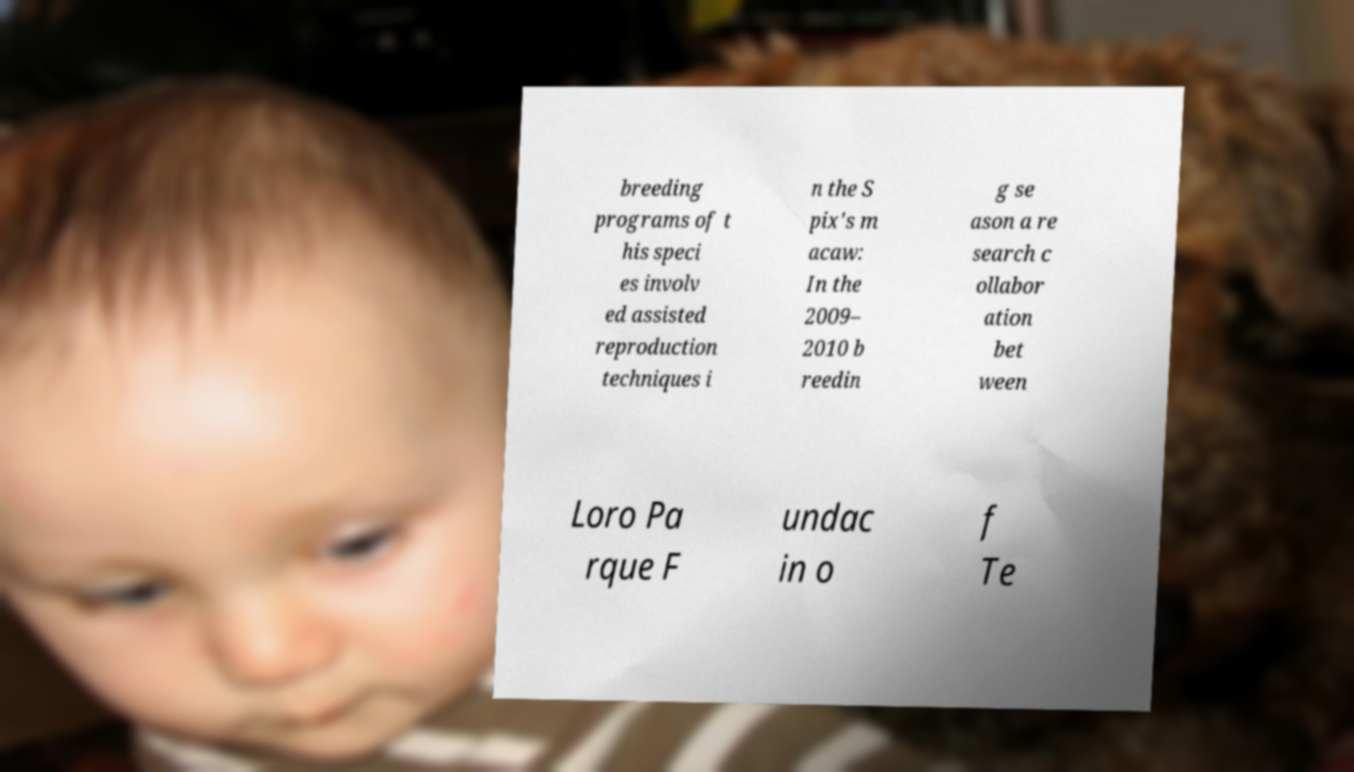What messages or text are displayed in this image? I need them in a readable, typed format. breeding programs of t his speci es involv ed assisted reproduction techniques i n the S pix's m acaw: In the 2009– 2010 b reedin g se ason a re search c ollabor ation bet ween Loro Pa rque F undac in o f Te 